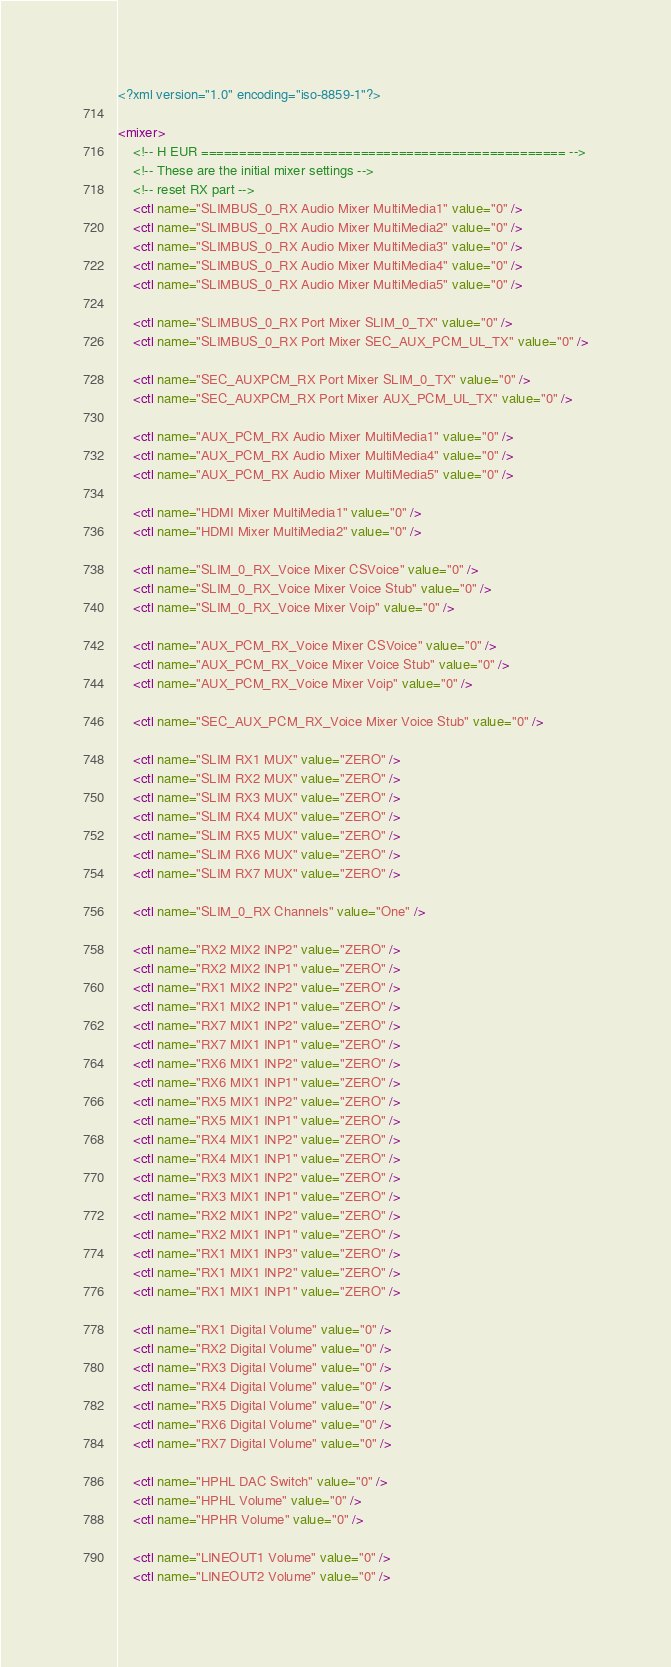<code> <loc_0><loc_0><loc_500><loc_500><_XML_><?xml version="1.0" encoding="iso-8859-1"?>

<mixer>
	<!-- H EUR ================================================ -->
	<!-- These are the initial mixer settings -->
	<!-- reset RX part -->
	<ctl name="SLIMBUS_0_RX Audio Mixer MultiMedia1" value="0" />
	<ctl name="SLIMBUS_0_RX Audio Mixer MultiMedia2" value="0" />
	<ctl name="SLIMBUS_0_RX Audio Mixer MultiMedia3" value="0" />
	<ctl name="SLIMBUS_0_RX Audio Mixer MultiMedia4" value="0" />
	<ctl name="SLIMBUS_0_RX Audio Mixer MultiMedia5" value="0" />

	<ctl name="SLIMBUS_0_RX Port Mixer SLIM_0_TX" value="0" />
	<ctl name="SLIMBUS_0_RX Port Mixer SEC_AUX_PCM_UL_TX" value="0" />

	<ctl name="SEC_AUXPCM_RX Port Mixer SLIM_0_TX" value="0" />
	<ctl name="SEC_AUXPCM_RX Port Mixer AUX_PCM_UL_TX" value="0" />

	<ctl name="AUX_PCM_RX Audio Mixer MultiMedia1" value="0" />
	<ctl name="AUX_PCM_RX Audio Mixer MultiMedia4" value="0" />
	<ctl name="AUX_PCM_RX Audio Mixer MultiMedia5" value="0" />

	<ctl name="HDMI Mixer MultiMedia1" value="0" />
	<ctl name="HDMI Mixer MultiMedia2" value="0" />

	<ctl name="SLIM_0_RX_Voice Mixer CSVoice" value="0" />
	<ctl name="SLIM_0_RX_Voice Mixer Voice Stub" value="0" />
	<ctl name="SLIM_0_RX_Voice Mixer Voip" value="0" />

	<ctl name="AUX_PCM_RX_Voice Mixer CSVoice" value="0" />
	<ctl name="AUX_PCM_RX_Voice Mixer Voice Stub" value="0" />
	<ctl name="AUX_PCM_RX_Voice Mixer Voip" value="0" />

	<ctl name="SEC_AUX_PCM_RX_Voice Mixer Voice Stub" value="0" />

	<ctl name="SLIM RX1 MUX" value="ZERO" />
	<ctl name="SLIM RX2 MUX" value="ZERO" />
	<ctl name="SLIM RX3 MUX" value="ZERO" />
	<ctl name="SLIM RX4 MUX" value="ZERO" />
	<ctl name="SLIM RX5 MUX" value="ZERO" />
	<ctl name="SLIM RX6 MUX" value="ZERO" />
	<ctl name="SLIM RX7 MUX" value="ZERO" />

	<ctl name="SLIM_0_RX Channels" value="One" />

	<ctl name="RX2 MIX2 INP2" value="ZERO" />
	<ctl name="RX2 MIX2 INP1" value="ZERO" />
	<ctl name="RX1 MIX2 INP2" value="ZERO" />
	<ctl name="RX1 MIX2 INP1" value="ZERO" />
	<ctl name="RX7 MIX1 INP2" value="ZERO" />
	<ctl name="RX7 MIX1 INP1" value="ZERO" />
	<ctl name="RX6 MIX1 INP2" value="ZERO" />
	<ctl name="RX6 MIX1 INP1" value="ZERO" />
	<ctl name="RX5 MIX1 INP2" value="ZERO" />
	<ctl name="RX5 MIX1 INP1" value="ZERO" />
	<ctl name="RX4 MIX1 INP2" value="ZERO" />
	<ctl name="RX4 MIX1 INP1" value="ZERO" />
	<ctl name="RX3 MIX1 INP2" value="ZERO" />
	<ctl name="RX3 MIX1 INP1" value="ZERO" />
	<ctl name="RX2 MIX1 INP2" value="ZERO" />
	<ctl name="RX2 MIX1 INP1" value="ZERO" />
	<ctl name="RX1 MIX1 INP3" value="ZERO" />
	<ctl name="RX1 MIX1 INP2" value="ZERO" />
	<ctl name="RX1 MIX1 INP1" value="ZERO" />

	<ctl name="RX1 Digital Volume" value="0" />
	<ctl name="RX2 Digital Volume" value="0" />
	<ctl name="RX3 Digital Volume" value="0" />
	<ctl name="RX4 Digital Volume" value="0" />
	<ctl name="RX5 Digital Volume" value="0" />
	<ctl name="RX6 Digital Volume" value="0" />
	<ctl name="RX7 Digital Volume" value="0" />

	<ctl name="HPHL DAC Switch" value="0" />
	<ctl name="HPHL Volume" value="0" />
	<ctl name="HPHR Volume" value="0" />

	<ctl name="LINEOUT1 Volume" value="0" />
	<ctl name="LINEOUT2 Volume" value="0" /></code> 